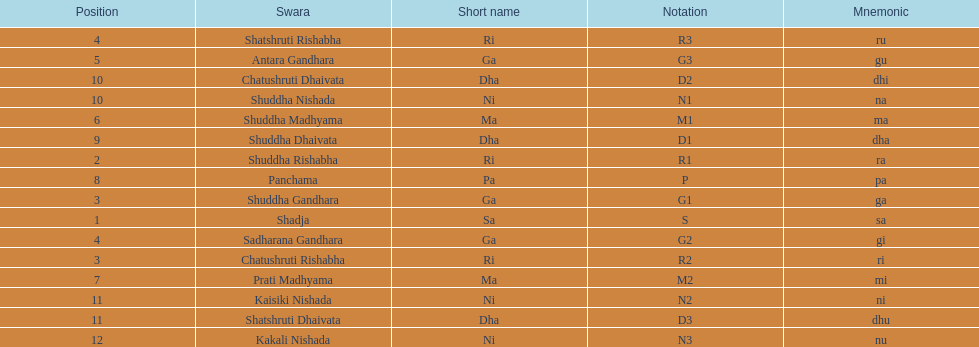What swara is above shatshruti dhaivata? Shuddha Nishada. 